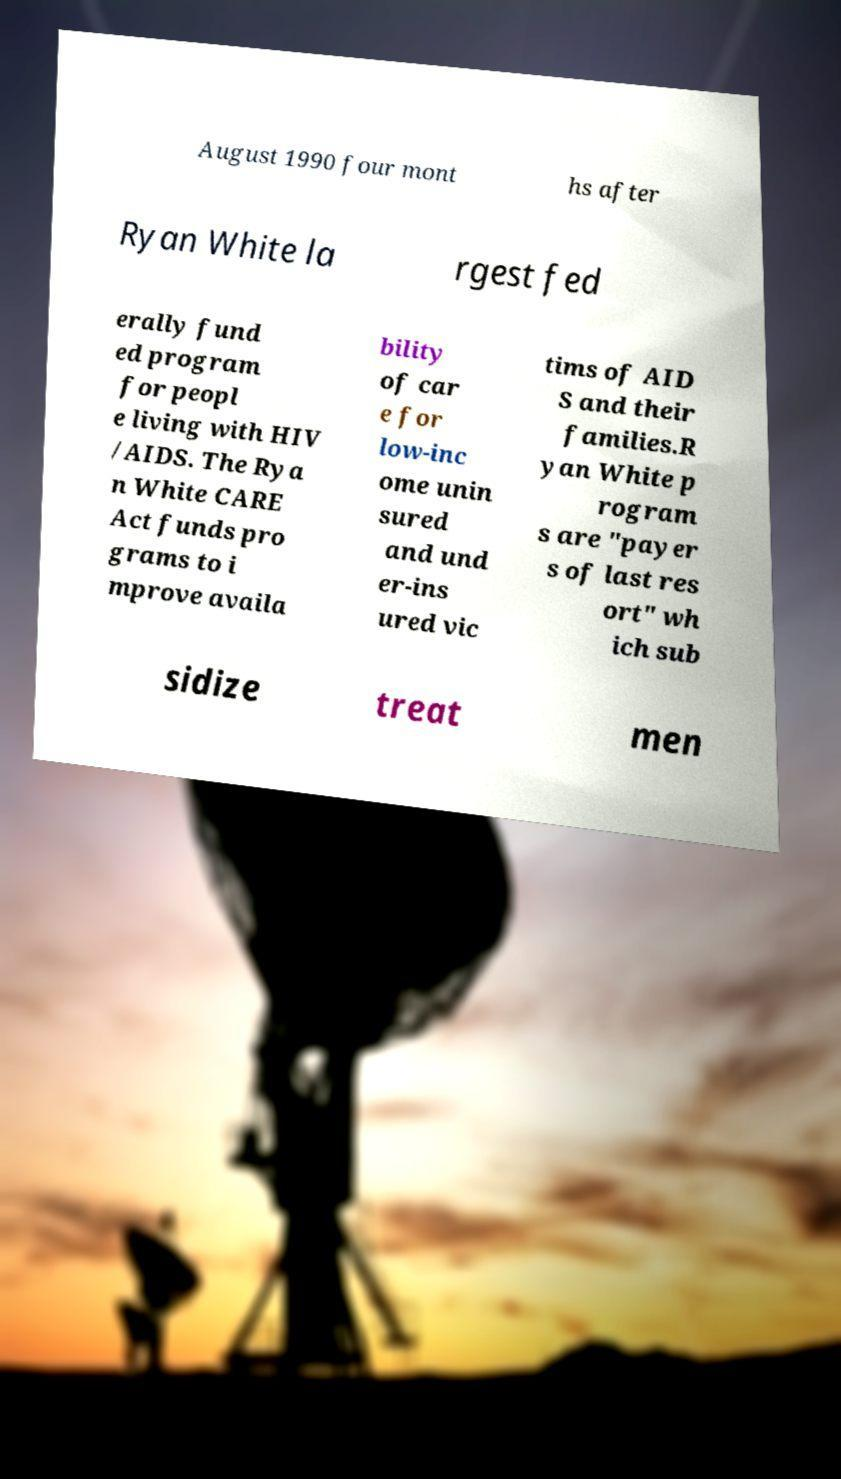There's text embedded in this image that I need extracted. Can you transcribe it verbatim? August 1990 four mont hs after Ryan White la rgest fed erally fund ed program for peopl e living with HIV /AIDS. The Rya n White CARE Act funds pro grams to i mprove availa bility of car e for low-inc ome unin sured and und er-ins ured vic tims of AID S and their families.R yan White p rogram s are "payer s of last res ort" wh ich sub sidize treat men 